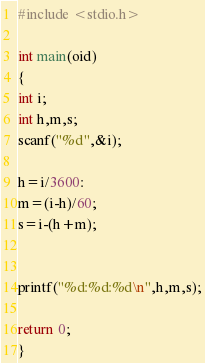Convert code to text. <code><loc_0><loc_0><loc_500><loc_500><_C_>#include <stdio.h>

int main(oid)
{
int i;
int h,m,s;
scanf("%d",&i);

h=i/3600:
m=(i-h)/60;
s=i-(h+m);


printf("%d:%d:%d\n",h,m,s);

return 0;
}
</code> 